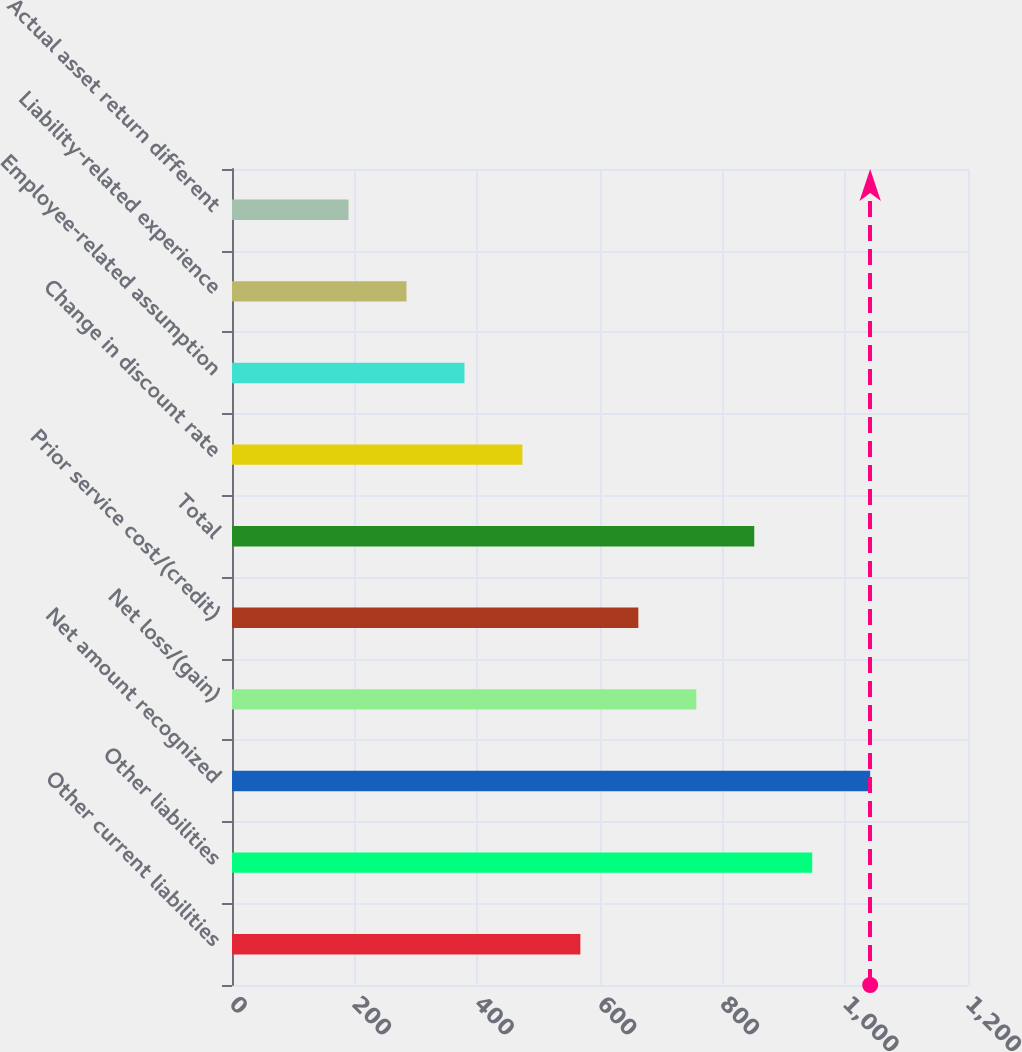Convert chart. <chart><loc_0><loc_0><loc_500><loc_500><bar_chart><fcel>Other current liabilities<fcel>Other liabilities<fcel>Net amount recognized<fcel>Net loss/(gain)<fcel>Prior service cost/(credit)<fcel>Total<fcel>Change in discount rate<fcel>Employee-related assumption<fcel>Liability-related experience<fcel>Actual asset return different<nl><fcel>568<fcel>946<fcel>1040.5<fcel>757<fcel>662.5<fcel>851.5<fcel>473.5<fcel>379<fcel>284.5<fcel>190<nl></chart> 